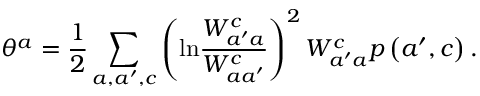Convert formula to latex. <formula><loc_0><loc_0><loc_500><loc_500>\theta ^ { a } = \frac { 1 } { 2 } \sum _ { a , a ^ { \prime } , c } \left ( \ln \frac { W _ { a ^ { \prime } a } ^ { c } } { W _ { a a ^ { \prime } } ^ { c } } \right ) ^ { 2 } W _ { a ^ { \prime } a } ^ { c } p \left ( a ^ { \prime } , c \right ) .</formula> 